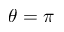Convert formula to latex. <formula><loc_0><loc_0><loc_500><loc_500>\theta = \pi</formula> 